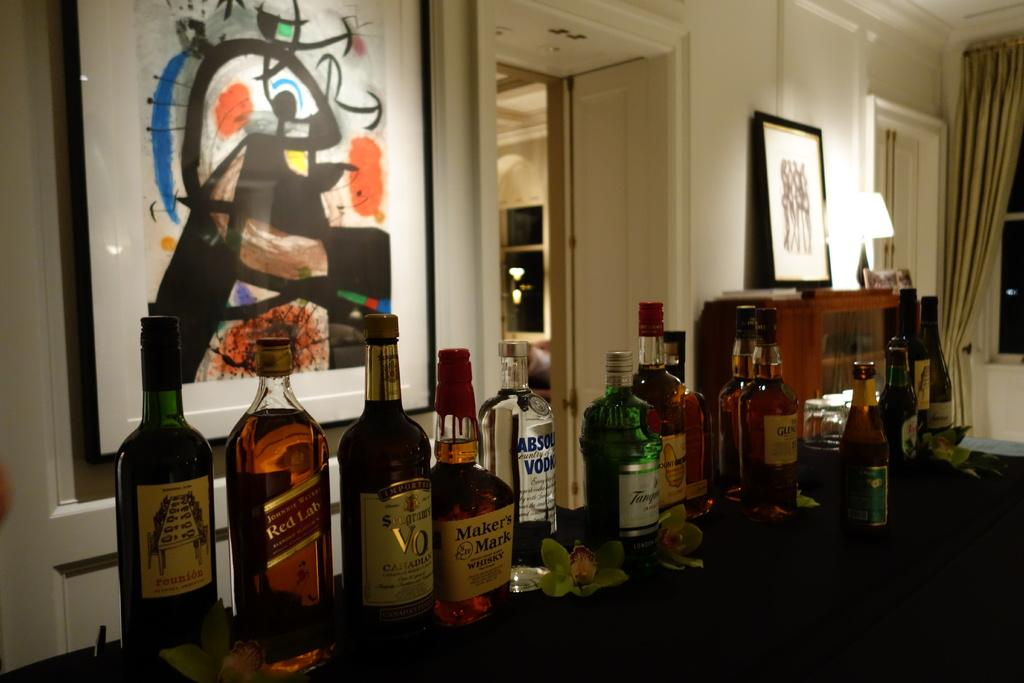<image>
Offer a succinct explanation of the picture presented. Various bottles of alcohols such as Absolut and Maker's Mark are on a table. 